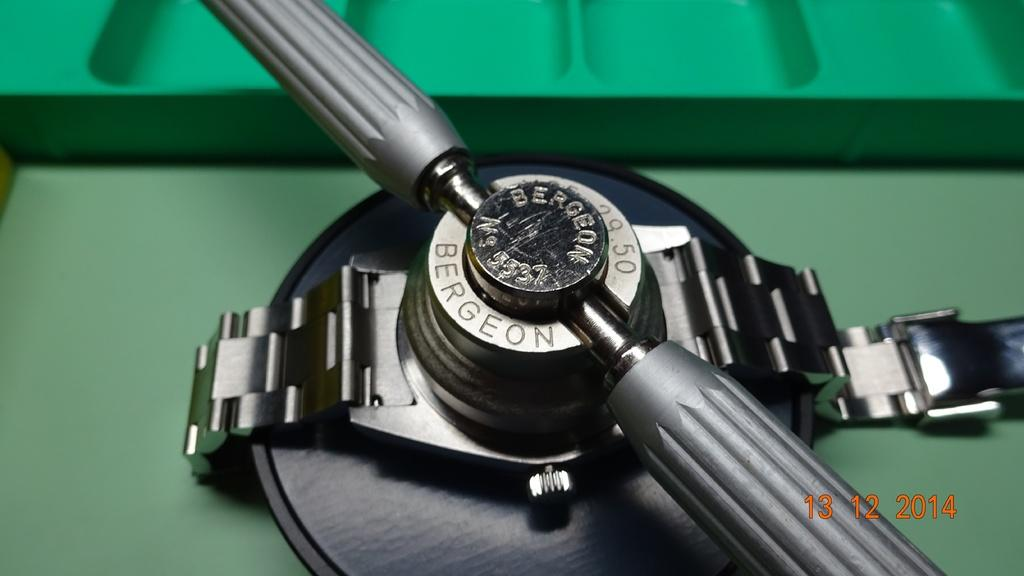Provide a one-sentence caption for the provided image. A watch with a piece of equipment over it in a picture dated 13/12/14. 